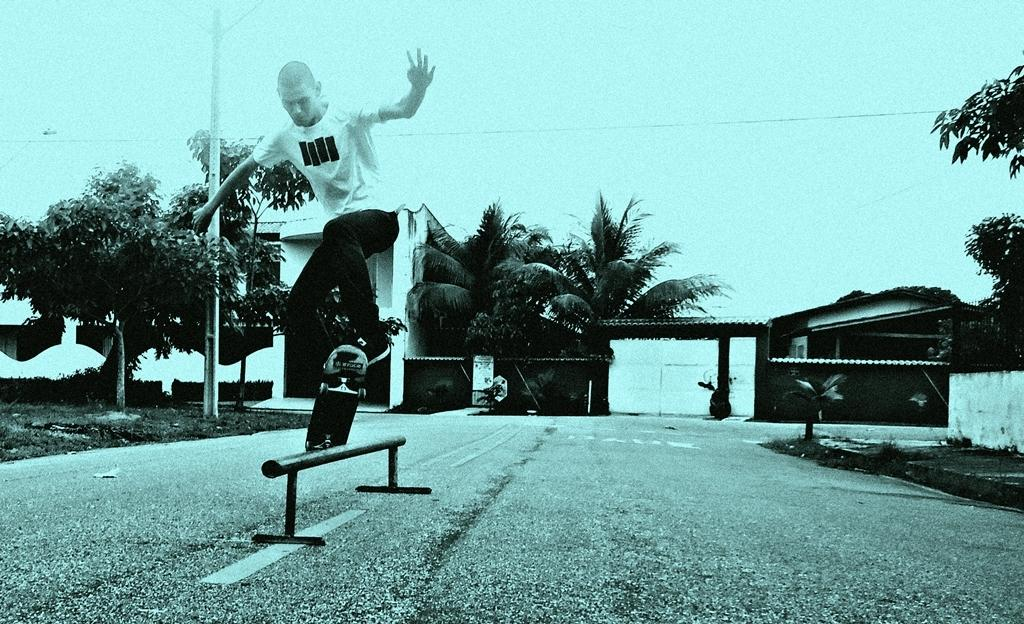What is the main subject of the image? There is a person in the image. What is the person doing in the image? The person is skating on a skateboarding in the image. What can be seen in the background of the image? There are trees and buildings visible in the background of the image. What type of ink is being used to write on the structure in the image? There is no structure or writing present in the image; it features a person skateboarding with trees and buildings in the background. 